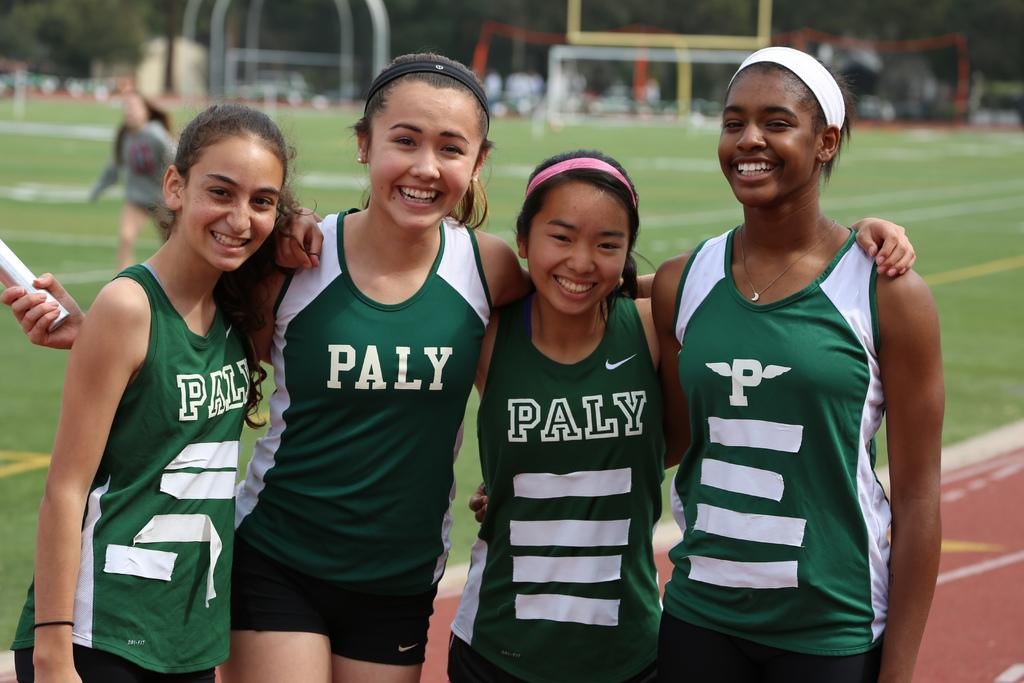<image>
Share a concise interpretation of the image provided. Four young ladies wearing green sports kit labeled Paly look very happy. 